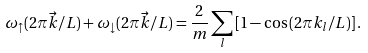<formula> <loc_0><loc_0><loc_500><loc_500>\omega _ { \uparrow } ( 2 \pi \vec { k } / L ) + \omega _ { \downarrow } ( 2 \pi \vec { k } / L ) = \frac { 2 } { m } \sum _ { l } \left [ 1 - \cos \left ( 2 \pi k _ { l } / L \right ) \right ] .</formula> 